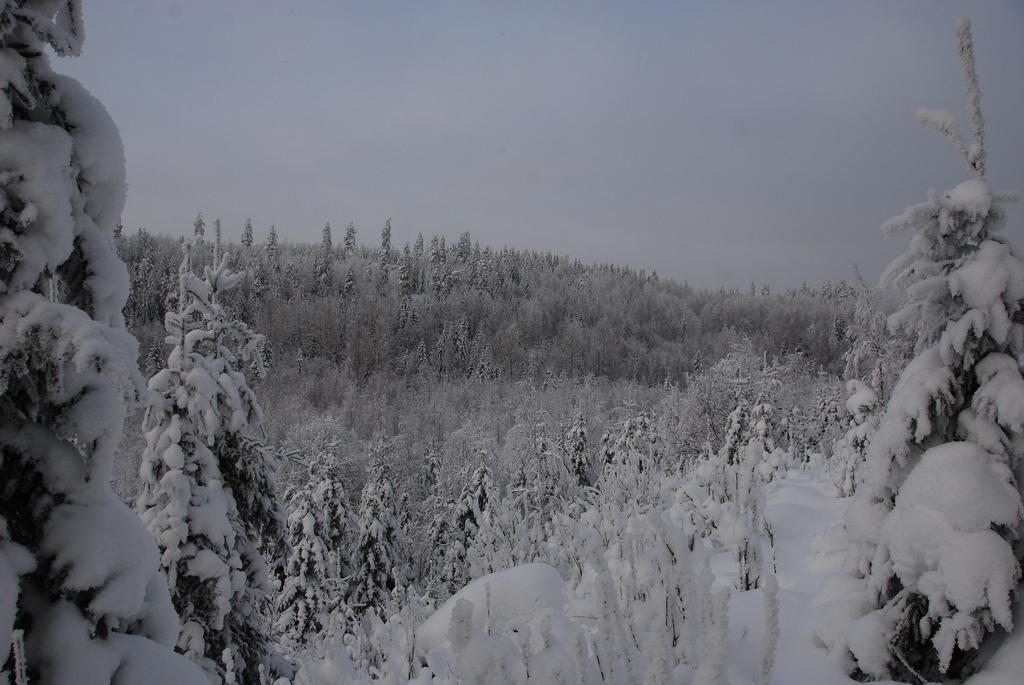Where was the picture taken? The picture was clicked outside the city. What is the condition of the trees in the foreground? There is a lot of snow on the trees in the foreground. What can be seen in the background of the picture? There is a sky visible in the background, and there are trees in the background. What type of drug is visible in the crate in the image? There is no crate or drug present in the image. How many nails can be seen in the image? There are no nails visible in the image. 